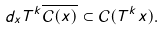<formula> <loc_0><loc_0><loc_500><loc_500>d _ { x } T ^ { k } \overline { \mathcal { C } ( x ) } \subset \mathcal { C } ( T ^ { k } x ) .</formula> 